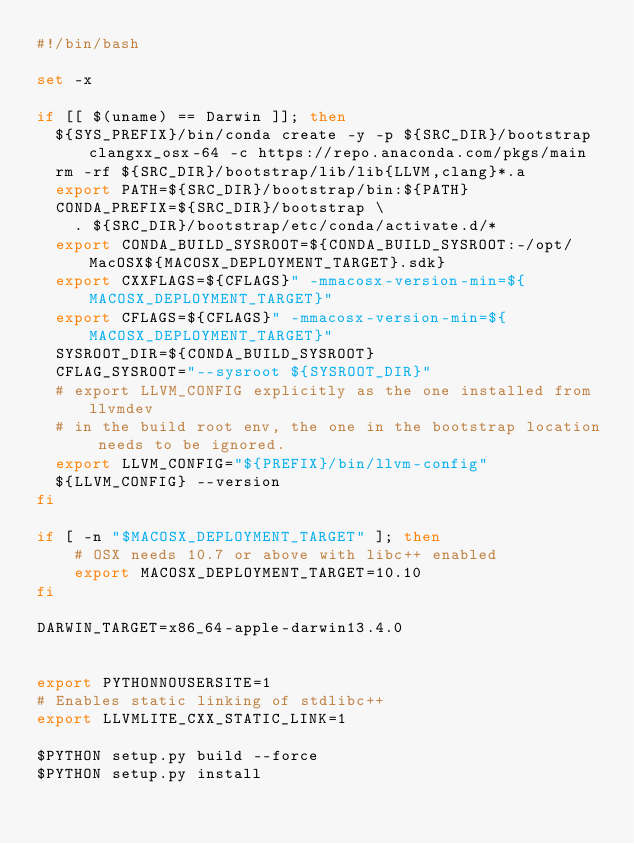Convert code to text. <code><loc_0><loc_0><loc_500><loc_500><_Bash_>#!/bin/bash

set -x

if [[ $(uname) == Darwin ]]; then
  ${SYS_PREFIX}/bin/conda create -y -p ${SRC_DIR}/bootstrap clangxx_osx-64 -c https://repo.anaconda.com/pkgs/main
  rm -rf ${SRC_DIR}/bootstrap/lib/lib{LLVM,clang}*.a
  export PATH=${SRC_DIR}/bootstrap/bin:${PATH}
  CONDA_PREFIX=${SRC_DIR}/bootstrap \
    . ${SRC_DIR}/bootstrap/etc/conda/activate.d/*
  export CONDA_BUILD_SYSROOT=${CONDA_BUILD_SYSROOT:-/opt/MacOSX${MACOSX_DEPLOYMENT_TARGET}.sdk}
  export CXXFLAGS=${CFLAGS}" -mmacosx-version-min=${MACOSX_DEPLOYMENT_TARGET}"
  export CFLAGS=${CFLAGS}" -mmacosx-version-min=${MACOSX_DEPLOYMENT_TARGET}"
  SYSROOT_DIR=${CONDA_BUILD_SYSROOT}
  CFLAG_SYSROOT="--sysroot ${SYSROOT_DIR}"
  # export LLVM_CONFIG explicitly as the one installed from llvmdev
  # in the build root env, the one in the bootstrap location needs to be ignored.
  export LLVM_CONFIG="${PREFIX}/bin/llvm-config"
  ${LLVM_CONFIG} --version
fi

if [ -n "$MACOSX_DEPLOYMENT_TARGET" ]; then
    # OSX needs 10.7 or above with libc++ enabled
    export MACOSX_DEPLOYMENT_TARGET=10.10
fi

DARWIN_TARGET=x86_64-apple-darwin13.4.0


export PYTHONNOUSERSITE=1
# Enables static linking of stdlibc++
export LLVMLITE_CXX_STATIC_LINK=1

$PYTHON setup.py build --force
$PYTHON setup.py install
</code> 